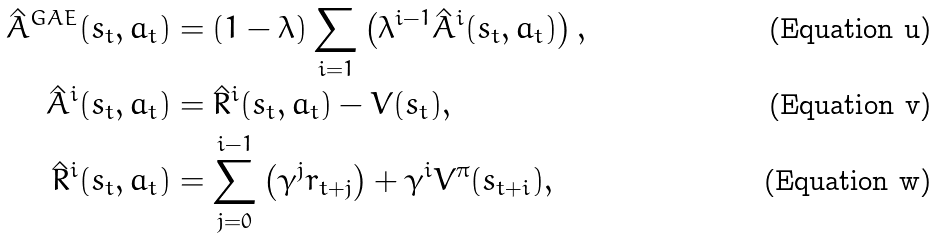Convert formula to latex. <formula><loc_0><loc_0><loc_500><loc_500>\hat { A } ^ { G A E } ( s _ { t } , a _ { t } ) & = ( 1 - \lambda ) \sum _ { i = 1 } \left ( \lambda ^ { i - 1 } \hat { A } ^ { i } ( s _ { t } , a _ { t } ) \right ) , \\ \hat { A } ^ { i } ( s _ { t } , a _ { t } ) & = \hat { R } ^ { i } ( s _ { t } , a _ { t } ) - V ( s _ { t } ) , \\ \hat { R } ^ { i } ( s _ { t } , a _ { t } ) & = \sum _ { j = 0 } ^ { i - 1 } \left ( \gamma ^ { j } r _ { t + j } \right ) + \gamma ^ { i } V ^ { \pi } ( s _ { t + i } ) ,</formula> 